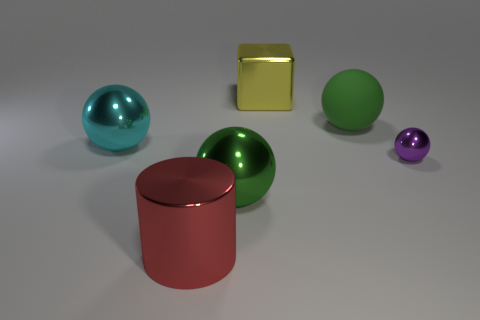How many objects are big spheres that are in front of the tiny purple metal thing or big things right of the cyan thing?
Your answer should be very brief. 4. Do the purple thing and the green ball on the right side of the big yellow metallic object have the same size?
Give a very brief answer. No. Are the green thing that is behind the small purple metal sphere and the big ball in front of the big cyan object made of the same material?
Your answer should be very brief. No. Are there an equal number of big metallic blocks to the left of the big cyan shiny ball and large yellow cubes that are behind the large metallic cube?
Ensure brevity in your answer.  Yes. How many shiny blocks have the same color as the small ball?
Keep it short and to the point. 0. What material is the big ball that is the same color as the big rubber object?
Provide a short and direct response. Metal. What number of matte things are either big brown cubes or small spheres?
Provide a succinct answer. 0. Do the big green thing behind the large cyan metallic sphere and the big green object to the left of the large yellow metal cube have the same shape?
Ensure brevity in your answer.  Yes. There is a red metal thing; what number of spheres are behind it?
Provide a succinct answer. 4. Is there a tiny cube made of the same material as the tiny purple thing?
Your answer should be compact. No. 